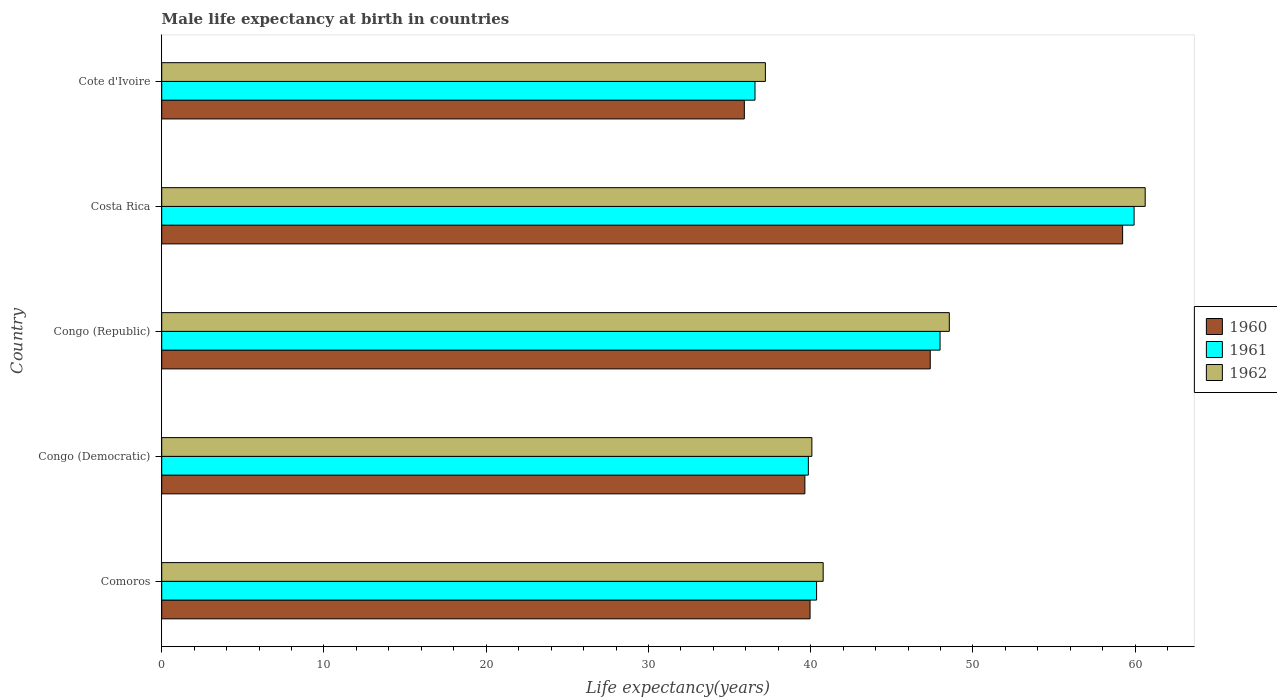How many groups of bars are there?
Give a very brief answer. 5. Are the number of bars per tick equal to the number of legend labels?
Your response must be concise. Yes. How many bars are there on the 5th tick from the top?
Your answer should be compact. 3. How many bars are there on the 4th tick from the bottom?
Your answer should be very brief. 3. What is the male life expectancy at birth in 1961 in Congo (Republic)?
Your answer should be compact. 47.97. Across all countries, what is the maximum male life expectancy at birth in 1960?
Offer a very short reply. 59.22. Across all countries, what is the minimum male life expectancy at birth in 1961?
Provide a succinct answer. 36.57. In which country was the male life expectancy at birth in 1960 maximum?
Your answer should be very brief. Costa Rica. In which country was the male life expectancy at birth in 1960 minimum?
Offer a terse response. Cote d'Ivoire. What is the total male life expectancy at birth in 1960 in the graph?
Your response must be concise. 222.1. What is the difference between the male life expectancy at birth in 1962 in Costa Rica and that in Cote d'Ivoire?
Provide a succinct answer. 23.41. What is the difference between the male life expectancy at birth in 1960 in Comoros and the male life expectancy at birth in 1961 in Congo (Democratic)?
Your answer should be very brief. 0.11. What is the average male life expectancy at birth in 1961 per country?
Give a very brief answer. 44.94. What is the difference between the male life expectancy at birth in 1961 and male life expectancy at birth in 1960 in Comoros?
Offer a terse response. 0.4. In how many countries, is the male life expectancy at birth in 1962 greater than 44 years?
Ensure brevity in your answer.  2. What is the ratio of the male life expectancy at birth in 1960 in Comoros to that in Congo (Republic)?
Give a very brief answer. 0.84. What is the difference between the highest and the second highest male life expectancy at birth in 1960?
Provide a succinct answer. 11.86. What is the difference between the highest and the lowest male life expectancy at birth in 1961?
Offer a very short reply. 23.36. In how many countries, is the male life expectancy at birth in 1960 greater than the average male life expectancy at birth in 1960 taken over all countries?
Make the answer very short. 2. Is the sum of the male life expectancy at birth in 1962 in Comoros and Congo (Republic) greater than the maximum male life expectancy at birth in 1960 across all countries?
Keep it short and to the point. Yes. What does the 3rd bar from the bottom in Cote d'Ivoire represents?
Provide a short and direct response. 1962. How many bars are there?
Give a very brief answer. 15. Are all the bars in the graph horizontal?
Provide a succinct answer. Yes. How many countries are there in the graph?
Your answer should be compact. 5. Are the values on the major ticks of X-axis written in scientific E-notation?
Your response must be concise. No. Does the graph contain any zero values?
Offer a terse response. No. Does the graph contain grids?
Your response must be concise. No. What is the title of the graph?
Offer a terse response. Male life expectancy at birth in countries. Does "1988" appear as one of the legend labels in the graph?
Your answer should be compact. No. What is the label or title of the X-axis?
Offer a very short reply. Life expectancy(years). What is the Life expectancy(years) in 1960 in Comoros?
Ensure brevity in your answer.  39.96. What is the Life expectancy(years) of 1961 in Comoros?
Provide a succinct answer. 40.36. What is the Life expectancy(years) in 1962 in Comoros?
Your response must be concise. 40.77. What is the Life expectancy(years) of 1960 in Congo (Democratic)?
Provide a short and direct response. 39.64. What is the Life expectancy(years) of 1961 in Congo (Democratic)?
Give a very brief answer. 39.85. What is the Life expectancy(years) of 1962 in Congo (Democratic)?
Keep it short and to the point. 40.07. What is the Life expectancy(years) of 1960 in Congo (Republic)?
Your answer should be compact. 47.37. What is the Life expectancy(years) of 1961 in Congo (Republic)?
Ensure brevity in your answer.  47.97. What is the Life expectancy(years) of 1962 in Congo (Republic)?
Provide a short and direct response. 48.54. What is the Life expectancy(years) of 1960 in Costa Rica?
Keep it short and to the point. 59.22. What is the Life expectancy(years) in 1961 in Costa Rica?
Your response must be concise. 59.93. What is the Life expectancy(years) in 1962 in Costa Rica?
Your answer should be very brief. 60.62. What is the Life expectancy(years) of 1960 in Cote d'Ivoire?
Offer a terse response. 35.91. What is the Life expectancy(years) in 1961 in Cote d'Ivoire?
Your answer should be compact. 36.57. What is the Life expectancy(years) in 1962 in Cote d'Ivoire?
Ensure brevity in your answer.  37.21. Across all countries, what is the maximum Life expectancy(years) of 1960?
Provide a succinct answer. 59.22. Across all countries, what is the maximum Life expectancy(years) of 1961?
Your answer should be very brief. 59.93. Across all countries, what is the maximum Life expectancy(years) of 1962?
Your answer should be very brief. 60.62. Across all countries, what is the minimum Life expectancy(years) in 1960?
Your response must be concise. 35.91. Across all countries, what is the minimum Life expectancy(years) of 1961?
Offer a terse response. 36.57. Across all countries, what is the minimum Life expectancy(years) in 1962?
Offer a very short reply. 37.21. What is the total Life expectancy(years) of 1960 in the graph?
Your answer should be compact. 222.1. What is the total Life expectancy(years) in 1961 in the graph?
Offer a very short reply. 224.69. What is the total Life expectancy(years) of 1962 in the graph?
Your response must be concise. 227.2. What is the difference between the Life expectancy(years) of 1960 in Comoros and that in Congo (Democratic)?
Offer a terse response. 0.32. What is the difference between the Life expectancy(years) in 1961 in Comoros and that in Congo (Democratic)?
Your answer should be compact. 0.51. What is the difference between the Life expectancy(years) of 1962 in Comoros and that in Congo (Democratic)?
Keep it short and to the point. 0.7. What is the difference between the Life expectancy(years) of 1960 in Comoros and that in Congo (Republic)?
Provide a succinct answer. -7.41. What is the difference between the Life expectancy(years) in 1961 in Comoros and that in Congo (Republic)?
Your response must be concise. -7.61. What is the difference between the Life expectancy(years) of 1962 in Comoros and that in Congo (Republic)?
Give a very brief answer. -7.77. What is the difference between the Life expectancy(years) of 1960 in Comoros and that in Costa Rica?
Provide a short and direct response. -19.26. What is the difference between the Life expectancy(years) in 1961 in Comoros and that in Costa Rica?
Give a very brief answer. -19.57. What is the difference between the Life expectancy(years) in 1962 in Comoros and that in Costa Rica?
Your answer should be compact. -19.85. What is the difference between the Life expectancy(years) of 1960 in Comoros and that in Cote d'Ivoire?
Provide a short and direct response. 4.05. What is the difference between the Life expectancy(years) in 1961 in Comoros and that in Cote d'Ivoire?
Your response must be concise. 3.79. What is the difference between the Life expectancy(years) of 1962 in Comoros and that in Cote d'Ivoire?
Your answer should be compact. 3.56. What is the difference between the Life expectancy(years) in 1960 in Congo (Democratic) and that in Congo (Republic)?
Keep it short and to the point. -7.73. What is the difference between the Life expectancy(years) of 1961 in Congo (Democratic) and that in Congo (Republic)?
Provide a short and direct response. -8.12. What is the difference between the Life expectancy(years) of 1962 in Congo (Democratic) and that in Congo (Republic)?
Your answer should be very brief. -8.47. What is the difference between the Life expectancy(years) of 1960 in Congo (Democratic) and that in Costa Rica?
Provide a short and direct response. -19.58. What is the difference between the Life expectancy(years) of 1961 in Congo (Democratic) and that in Costa Rica?
Make the answer very short. -20.08. What is the difference between the Life expectancy(years) in 1962 in Congo (Democratic) and that in Costa Rica?
Provide a succinct answer. -20.54. What is the difference between the Life expectancy(years) in 1960 in Congo (Democratic) and that in Cote d'Ivoire?
Make the answer very short. 3.73. What is the difference between the Life expectancy(years) of 1961 in Congo (Democratic) and that in Cote d'Ivoire?
Make the answer very short. 3.29. What is the difference between the Life expectancy(years) of 1962 in Congo (Democratic) and that in Cote d'Ivoire?
Your answer should be compact. 2.87. What is the difference between the Life expectancy(years) in 1960 in Congo (Republic) and that in Costa Rica?
Offer a terse response. -11.86. What is the difference between the Life expectancy(years) of 1961 in Congo (Republic) and that in Costa Rica?
Make the answer very short. -11.96. What is the difference between the Life expectancy(years) of 1962 in Congo (Republic) and that in Costa Rica?
Provide a short and direct response. -12.07. What is the difference between the Life expectancy(years) of 1960 in Congo (Republic) and that in Cote d'Ivoire?
Offer a very short reply. 11.46. What is the difference between the Life expectancy(years) in 1961 in Congo (Republic) and that in Cote d'Ivoire?
Offer a very short reply. 11.41. What is the difference between the Life expectancy(years) in 1962 in Congo (Republic) and that in Cote d'Ivoire?
Offer a very short reply. 11.34. What is the difference between the Life expectancy(years) of 1960 in Costa Rica and that in Cote d'Ivoire?
Offer a very short reply. 23.32. What is the difference between the Life expectancy(years) in 1961 in Costa Rica and that in Cote d'Ivoire?
Provide a succinct answer. 23.36. What is the difference between the Life expectancy(years) of 1962 in Costa Rica and that in Cote d'Ivoire?
Your response must be concise. 23.41. What is the difference between the Life expectancy(years) in 1960 in Comoros and the Life expectancy(years) in 1961 in Congo (Democratic)?
Give a very brief answer. 0.1. What is the difference between the Life expectancy(years) of 1960 in Comoros and the Life expectancy(years) of 1962 in Congo (Democratic)?
Offer a terse response. -0.11. What is the difference between the Life expectancy(years) of 1961 in Comoros and the Life expectancy(years) of 1962 in Congo (Democratic)?
Ensure brevity in your answer.  0.29. What is the difference between the Life expectancy(years) in 1960 in Comoros and the Life expectancy(years) in 1961 in Congo (Republic)?
Provide a short and direct response. -8.01. What is the difference between the Life expectancy(years) in 1960 in Comoros and the Life expectancy(years) in 1962 in Congo (Republic)?
Offer a terse response. -8.58. What is the difference between the Life expectancy(years) in 1961 in Comoros and the Life expectancy(years) in 1962 in Congo (Republic)?
Your answer should be very brief. -8.18. What is the difference between the Life expectancy(years) of 1960 in Comoros and the Life expectancy(years) of 1961 in Costa Rica?
Make the answer very short. -19.97. What is the difference between the Life expectancy(years) of 1960 in Comoros and the Life expectancy(years) of 1962 in Costa Rica?
Ensure brevity in your answer.  -20.66. What is the difference between the Life expectancy(years) in 1961 in Comoros and the Life expectancy(years) in 1962 in Costa Rica?
Your response must be concise. -20.25. What is the difference between the Life expectancy(years) in 1960 in Comoros and the Life expectancy(years) in 1961 in Cote d'Ivoire?
Provide a short and direct response. 3.39. What is the difference between the Life expectancy(years) of 1960 in Comoros and the Life expectancy(years) of 1962 in Cote d'Ivoire?
Provide a succinct answer. 2.75. What is the difference between the Life expectancy(years) in 1961 in Comoros and the Life expectancy(years) in 1962 in Cote d'Ivoire?
Offer a very short reply. 3.15. What is the difference between the Life expectancy(years) in 1960 in Congo (Democratic) and the Life expectancy(years) in 1961 in Congo (Republic)?
Your response must be concise. -8.33. What is the difference between the Life expectancy(years) in 1960 in Congo (Democratic) and the Life expectancy(years) in 1962 in Congo (Republic)?
Ensure brevity in your answer.  -8.9. What is the difference between the Life expectancy(years) of 1961 in Congo (Democratic) and the Life expectancy(years) of 1962 in Congo (Republic)?
Your response must be concise. -8.69. What is the difference between the Life expectancy(years) in 1960 in Congo (Democratic) and the Life expectancy(years) in 1961 in Costa Rica?
Your response must be concise. -20.29. What is the difference between the Life expectancy(years) in 1960 in Congo (Democratic) and the Life expectancy(years) in 1962 in Costa Rica?
Ensure brevity in your answer.  -20.98. What is the difference between the Life expectancy(years) in 1961 in Congo (Democratic) and the Life expectancy(years) in 1962 in Costa Rica?
Give a very brief answer. -20.76. What is the difference between the Life expectancy(years) of 1960 in Congo (Democratic) and the Life expectancy(years) of 1961 in Cote d'Ivoire?
Your answer should be compact. 3.07. What is the difference between the Life expectancy(years) in 1960 in Congo (Democratic) and the Life expectancy(years) in 1962 in Cote d'Ivoire?
Give a very brief answer. 2.43. What is the difference between the Life expectancy(years) of 1961 in Congo (Democratic) and the Life expectancy(years) of 1962 in Cote d'Ivoire?
Your response must be concise. 2.65. What is the difference between the Life expectancy(years) of 1960 in Congo (Republic) and the Life expectancy(years) of 1961 in Costa Rica?
Ensure brevity in your answer.  -12.56. What is the difference between the Life expectancy(years) in 1960 in Congo (Republic) and the Life expectancy(years) in 1962 in Costa Rica?
Give a very brief answer. -13.25. What is the difference between the Life expectancy(years) in 1961 in Congo (Republic) and the Life expectancy(years) in 1962 in Costa Rica?
Your answer should be compact. -12.64. What is the difference between the Life expectancy(years) in 1960 in Congo (Republic) and the Life expectancy(years) in 1961 in Cote d'Ivoire?
Keep it short and to the point. 10.8. What is the difference between the Life expectancy(years) of 1960 in Congo (Republic) and the Life expectancy(years) of 1962 in Cote d'Ivoire?
Provide a succinct answer. 10.16. What is the difference between the Life expectancy(years) in 1961 in Congo (Republic) and the Life expectancy(years) in 1962 in Cote d'Ivoire?
Provide a short and direct response. 10.77. What is the difference between the Life expectancy(years) of 1960 in Costa Rica and the Life expectancy(years) of 1961 in Cote d'Ivoire?
Your answer should be compact. 22.66. What is the difference between the Life expectancy(years) in 1960 in Costa Rica and the Life expectancy(years) in 1962 in Cote d'Ivoire?
Offer a terse response. 22.02. What is the difference between the Life expectancy(years) in 1961 in Costa Rica and the Life expectancy(years) in 1962 in Cote d'Ivoire?
Offer a very short reply. 22.72. What is the average Life expectancy(years) in 1960 per country?
Your response must be concise. 44.42. What is the average Life expectancy(years) of 1961 per country?
Keep it short and to the point. 44.94. What is the average Life expectancy(years) of 1962 per country?
Ensure brevity in your answer.  45.44. What is the difference between the Life expectancy(years) of 1960 and Life expectancy(years) of 1961 in Comoros?
Your response must be concise. -0.4. What is the difference between the Life expectancy(years) of 1960 and Life expectancy(years) of 1962 in Comoros?
Your answer should be very brief. -0.81. What is the difference between the Life expectancy(years) in 1961 and Life expectancy(years) in 1962 in Comoros?
Your answer should be very brief. -0.41. What is the difference between the Life expectancy(years) of 1960 and Life expectancy(years) of 1961 in Congo (Democratic)?
Your response must be concise. -0.21. What is the difference between the Life expectancy(years) in 1960 and Life expectancy(years) in 1962 in Congo (Democratic)?
Provide a succinct answer. -0.43. What is the difference between the Life expectancy(years) in 1961 and Life expectancy(years) in 1962 in Congo (Democratic)?
Offer a very short reply. -0.22. What is the difference between the Life expectancy(years) of 1960 and Life expectancy(years) of 1961 in Congo (Republic)?
Give a very brief answer. -0.6. What is the difference between the Life expectancy(years) of 1960 and Life expectancy(years) of 1962 in Congo (Republic)?
Ensure brevity in your answer.  -1.18. What is the difference between the Life expectancy(years) of 1961 and Life expectancy(years) of 1962 in Congo (Republic)?
Your answer should be compact. -0.57. What is the difference between the Life expectancy(years) in 1960 and Life expectancy(years) in 1961 in Costa Rica?
Ensure brevity in your answer.  -0.71. What is the difference between the Life expectancy(years) in 1960 and Life expectancy(years) in 1962 in Costa Rica?
Provide a succinct answer. -1.39. What is the difference between the Life expectancy(years) in 1961 and Life expectancy(years) in 1962 in Costa Rica?
Your answer should be compact. -0.68. What is the difference between the Life expectancy(years) in 1960 and Life expectancy(years) in 1961 in Cote d'Ivoire?
Keep it short and to the point. -0.66. What is the difference between the Life expectancy(years) of 1960 and Life expectancy(years) of 1962 in Cote d'Ivoire?
Give a very brief answer. -1.3. What is the difference between the Life expectancy(years) of 1961 and Life expectancy(years) of 1962 in Cote d'Ivoire?
Make the answer very short. -0.64. What is the ratio of the Life expectancy(years) in 1961 in Comoros to that in Congo (Democratic)?
Make the answer very short. 1.01. What is the ratio of the Life expectancy(years) in 1962 in Comoros to that in Congo (Democratic)?
Offer a terse response. 1.02. What is the ratio of the Life expectancy(years) of 1960 in Comoros to that in Congo (Republic)?
Your answer should be compact. 0.84. What is the ratio of the Life expectancy(years) in 1961 in Comoros to that in Congo (Republic)?
Make the answer very short. 0.84. What is the ratio of the Life expectancy(years) of 1962 in Comoros to that in Congo (Republic)?
Your answer should be compact. 0.84. What is the ratio of the Life expectancy(years) of 1960 in Comoros to that in Costa Rica?
Provide a short and direct response. 0.67. What is the ratio of the Life expectancy(years) of 1961 in Comoros to that in Costa Rica?
Ensure brevity in your answer.  0.67. What is the ratio of the Life expectancy(years) in 1962 in Comoros to that in Costa Rica?
Keep it short and to the point. 0.67. What is the ratio of the Life expectancy(years) of 1960 in Comoros to that in Cote d'Ivoire?
Keep it short and to the point. 1.11. What is the ratio of the Life expectancy(years) in 1961 in Comoros to that in Cote d'Ivoire?
Ensure brevity in your answer.  1.1. What is the ratio of the Life expectancy(years) in 1962 in Comoros to that in Cote d'Ivoire?
Your response must be concise. 1.1. What is the ratio of the Life expectancy(years) in 1960 in Congo (Democratic) to that in Congo (Republic)?
Provide a short and direct response. 0.84. What is the ratio of the Life expectancy(years) of 1961 in Congo (Democratic) to that in Congo (Republic)?
Give a very brief answer. 0.83. What is the ratio of the Life expectancy(years) of 1962 in Congo (Democratic) to that in Congo (Republic)?
Provide a short and direct response. 0.83. What is the ratio of the Life expectancy(years) in 1960 in Congo (Democratic) to that in Costa Rica?
Your answer should be compact. 0.67. What is the ratio of the Life expectancy(years) of 1961 in Congo (Democratic) to that in Costa Rica?
Keep it short and to the point. 0.67. What is the ratio of the Life expectancy(years) in 1962 in Congo (Democratic) to that in Costa Rica?
Offer a very short reply. 0.66. What is the ratio of the Life expectancy(years) of 1960 in Congo (Democratic) to that in Cote d'Ivoire?
Keep it short and to the point. 1.1. What is the ratio of the Life expectancy(years) in 1961 in Congo (Democratic) to that in Cote d'Ivoire?
Provide a succinct answer. 1.09. What is the ratio of the Life expectancy(years) in 1962 in Congo (Democratic) to that in Cote d'Ivoire?
Your response must be concise. 1.08. What is the ratio of the Life expectancy(years) of 1960 in Congo (Republic) to that in Costa Rica?
Offer a very short reply. 0.8. What is the ratio of the Life expectancy(years) of 1961 in Congo (Republic) to that in Costa Rica?
Give a very brief answer. 0.8. What is the ratio of the Life expectancy(years) of 1962 in Congo (Republic) to that in Costa Rica?
Your response must be concise. 0.8. What is the ratio of the Life expectancy(years) in 1960 in Congo (Republic) to that in Cote d'Ivoire?
Offer a terse response. 1.32. What is the ratio of the Life expectancy(years) of 1961 in Congo (Republic) to that in Cote d'Ivoire?
Your response must be concise. 1.31. What is the ratio of the Life expectancy(years) in 1962 in Congo (Republic) to that in Cote d'Ivoire?
Provide a short and direct response. 1.3. What is the ratio of the Life expectancy(years) in 1960 in Costa Rica to that in Cote d'Ivoire?
Your response must be concise. 1.65. What is the ratio of the Life expectancy(years) of 1961 in Costa Rica to that in Cote d'Ivoire?
Provide a short and direct response. 1.64. What is the ratio of the Life expectancy(years) of 1962 in Costa Rica to that in Cote d'Ivoire?
Make the answer very short. 1.63. What is the difference between the highest and the second highest Life expectancy(years) in 1960?
Provide a succinct answer. 11.86. What is the difference between the highest and the second highest Life expectancy(years) in 1961?
Your response must be concise. 11.96. What is the difference between the highest and the second highest Life expectancy(years) in 1962?
Keep it short and to the point. 12.07. What is the difference between the highest and the lowest Life expectancy(years) in 1960?
Provide a succinct answer. 23.32. What is the difference between the highest and the lowest Life expectancy(years) in 1961?
Offer a very short reply. 23.36. What is the difference between the highest and the lowest Life expectancy(years) of 1962?
Your answer should be compact. 23.41. 